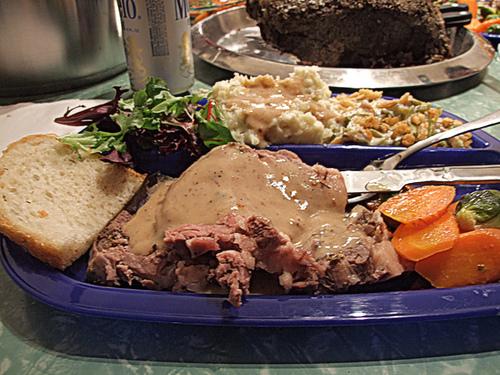Do this meal contain carbs?
Be succinct. Yes. Is meat in the image?
Short answer required. Yes. Are there any greens in this photo?
Write a very short answer. Yes. 